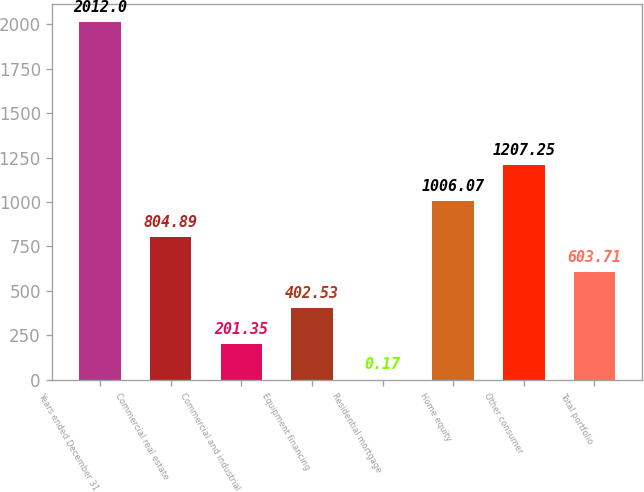<chart> <loc_0><loc_0><loc_500><loc_500><bar_chart><fcel>Years ended December 31<fcel>Commercial real estate<fcel>Commercial and industrial<fcel>Equipment financing<fcel>Residential mortgage<fcel>Home equity<fcel>Other consumer<fcel>Total portfolio<nl><fcel>2012<fcel>804.89<fcel>201.35<fcel>402.53<fcel>0.17<fcel>1006.07<fcel>1207.25<fcel>603.71<nl></chart> 